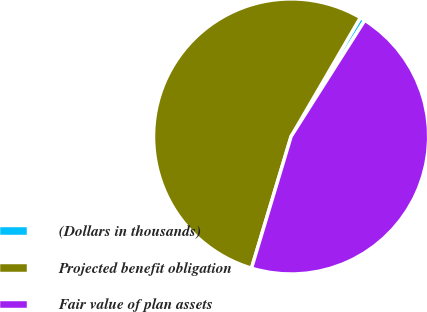Convert chart. <chart><loc_0><loc_0><loc_500><loc_500><pie_chart><fcel>(Dollars in thousands)<fcel>Projected benefit obligation<fcel>Fair value of plan assets<nl><fcel>0.6%<fcel>53.75%<fcel>45.65%<nl></chart> 